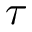<formula> <loc_0><loc_0><loc_500><loc_500>\tau</formula> 